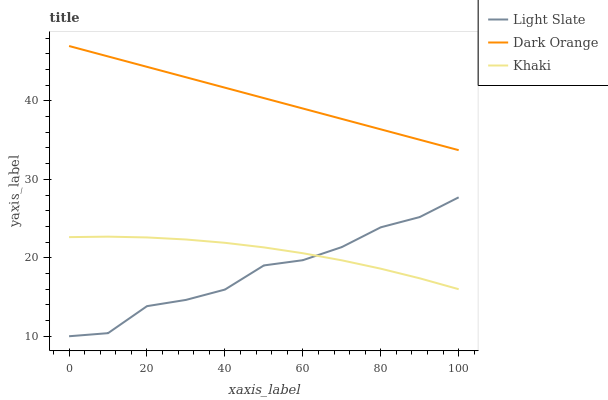Does Light Slate have the minimum area under the curve?
Answer yes or no. Yes. Does Dark Orange have the maximum area under the curve?
Answer yes or no. Yes. Does Khaki have the minimum area under the curve?
Answer yes or no. No. Does Khaki have the maximum area under the curve?
Answer yes or no. No. Is Dark Orange the smoothest?
Answer yes or no. Yes. Is Light Slate the roughest?
Answer yes or no. Yes. Is Khaki the smoothest?
Answer yes or no. No. Is Khaki the roughest?
Answer yes or no. No. Does Light Slate have the lowest value?
Answer yes or no. Yes. Does Khaki have the lowest value?
Answer yes or no. No. Does Dark Orange have the highest value?
Answer yes or no. Yes. Does Khaki have the highest value?
Answer yes or no. No. Is Khaki less than Dark Orange?
Answer yes or no. Yes. Is Dark Orange greater than Light Slate?
Answer yes or no. Yes. Does Light Slate intersect Khaki?
Answer yes or no. Yes. Is Light Slate less than Khaki?
Answer yes or no. No. Is Light Slate greater than Khaki?
Answer yes or no. No. Does Khaki intersect Dark Orange?
Answer yes or no. No. 